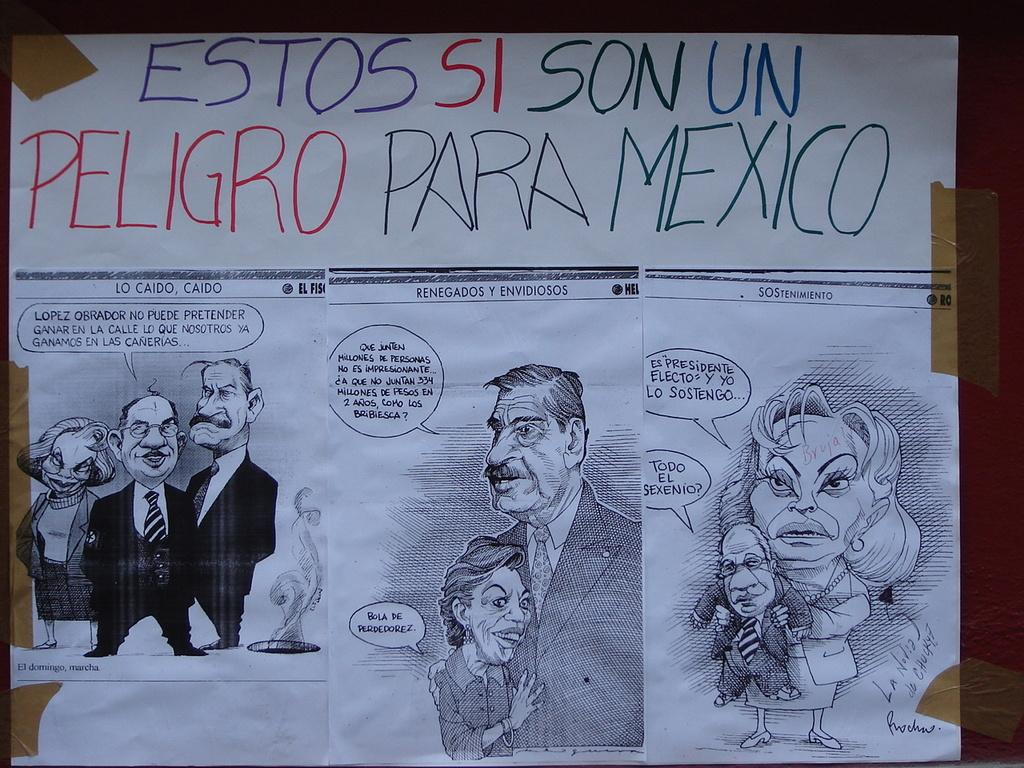What is attached to the wall in the image? There is a paper pasted on a wall in the image. What can be found on the paper? There is text written on the paper and pictures pasted on it. What type of dress is being traded in the image? There is no dress or trade activity present in the image; it only features a paper with text and pictures on a wall. 